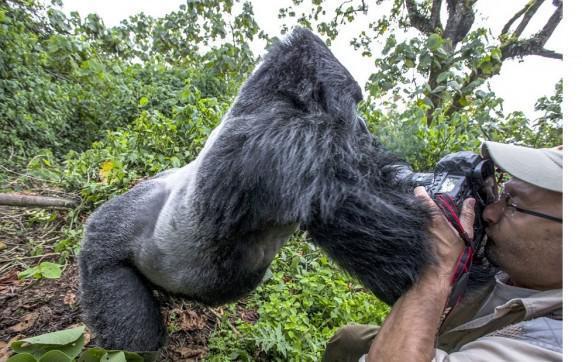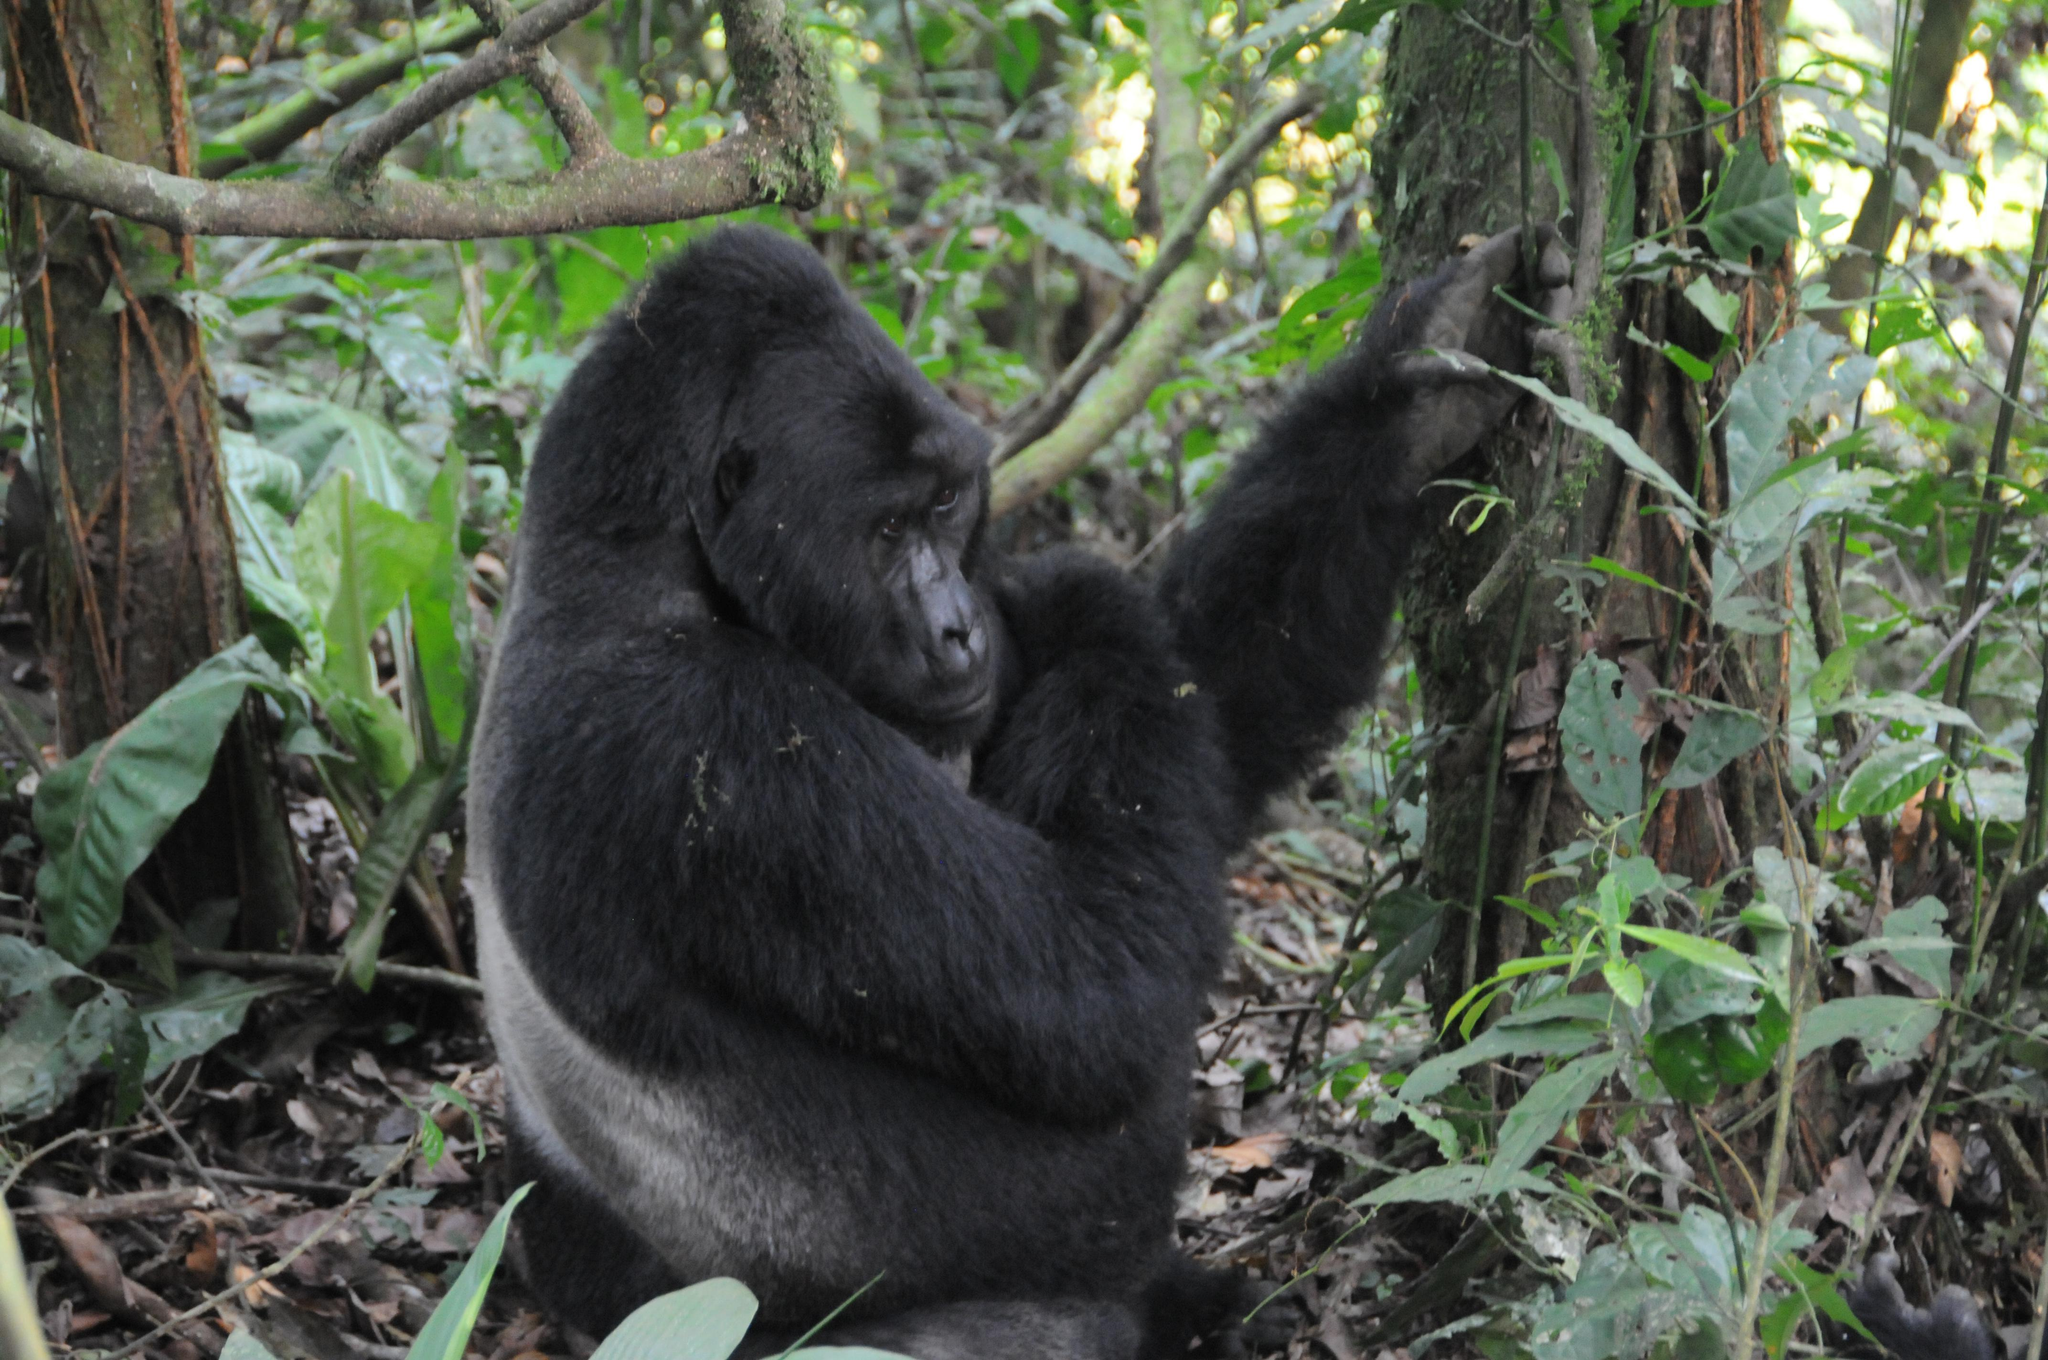The first image is the image on the left, the second image is the image on the right. Given the left and right images, does the statement "The left image contains a human interacting with a gorilla." hold true? Answer yes or no. Yes. The first image is the image on the left, the second image is the image on the right. Evaluate the accuracy of this statement regarding the images: "A person holding a camera is near an adult gorilla in the left image.". Is it true? Answer yes or no. Yes. 